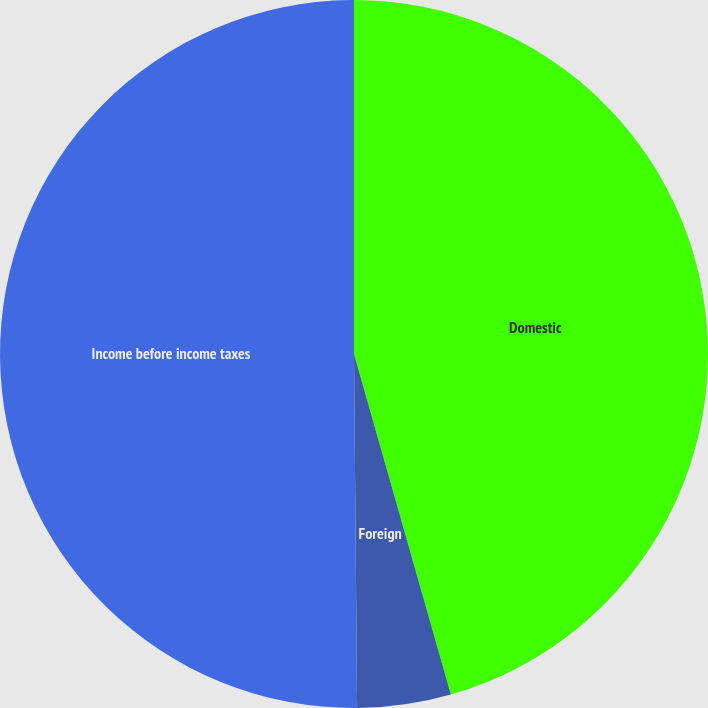Convert chart to OTSL. <chart><loc_0><loc_0><loc_500><loc_500><pie_chart><fcel>Domestic<fcel>Foreign<fcel>Income before income taxes<nl><fcel>45.59%<fcel>4.27%<fcel>50.14%<nl></chart> 